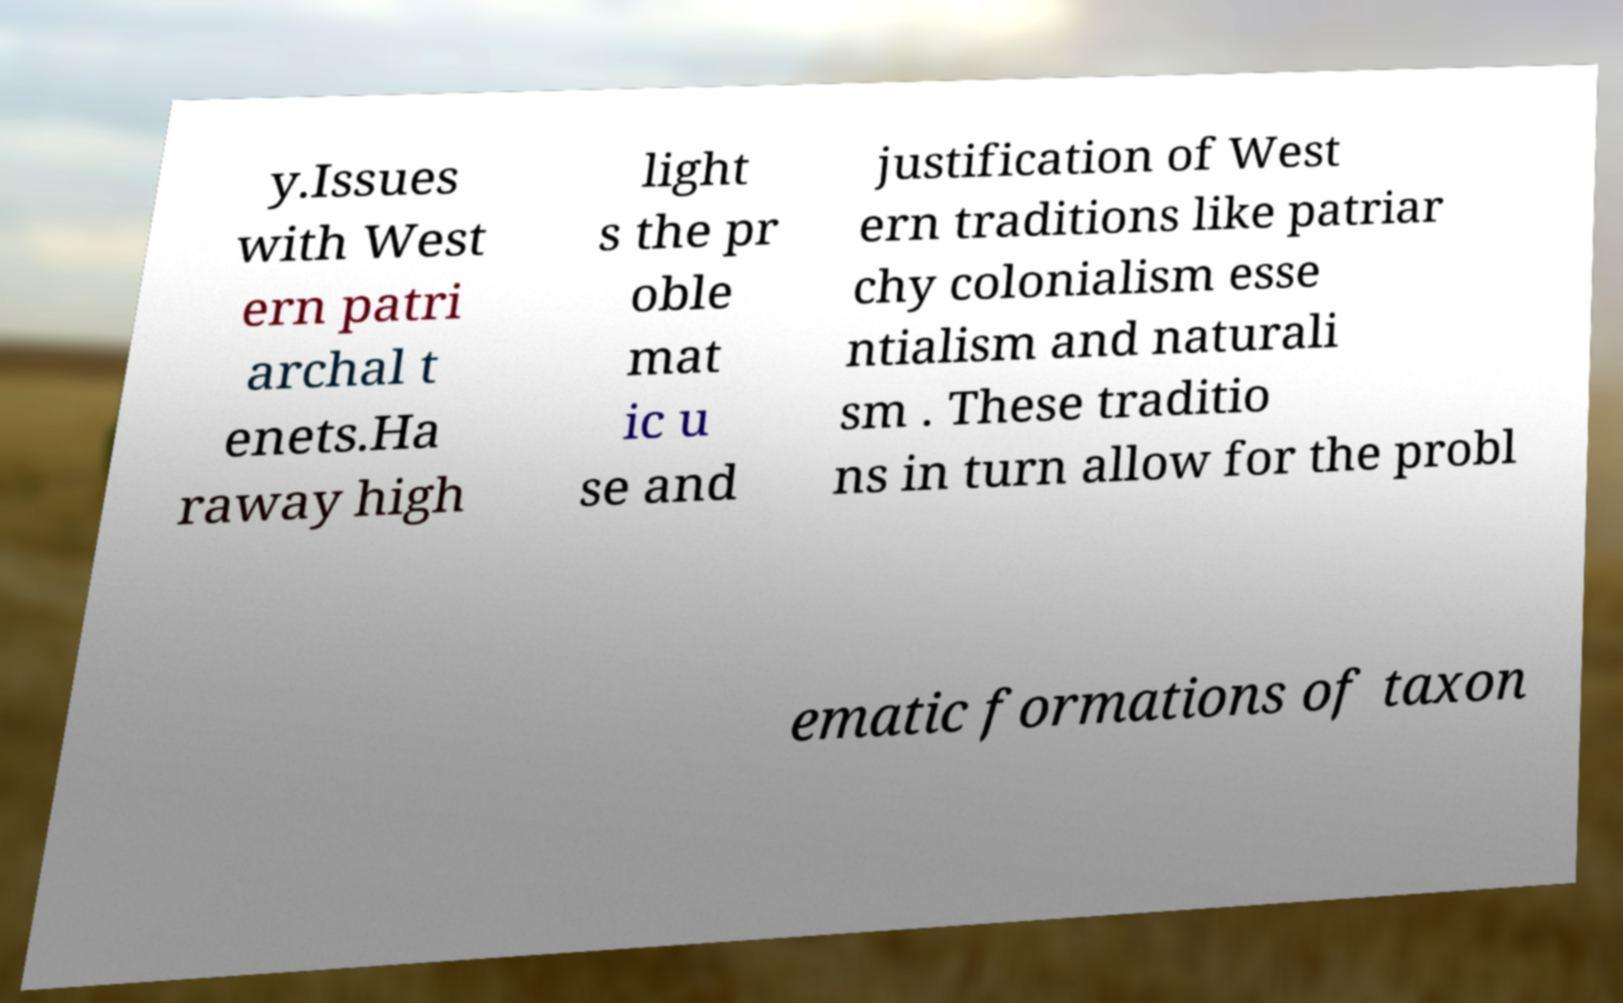Could you assist in decoding the text presented in this image and type it out clearly? y.Issues with West ern patri archal t enets.Ha raway high light s the pr oble mat ic u se and justification of West ern traditions like patriar chy colonialism esse ntialism and naturali sm . These traditio ns in turn allow for the probl ematic formations of taxon 